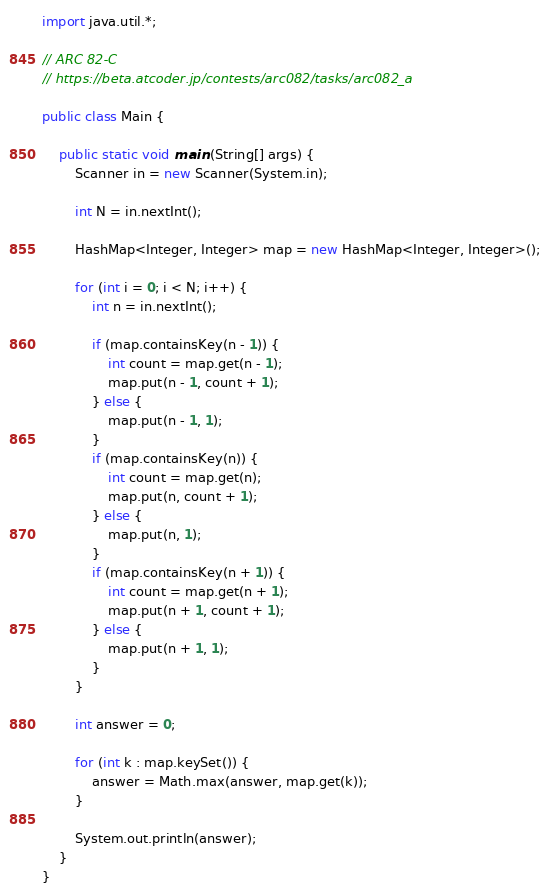Convert code to text. <code><loc_0><loc_0><loc_500><loc_500><_Java_>import java.util.*;

// ARC 82-C
// https://beta.atcoder.jp/contests/arc082/tasks/arc082_a

public class Main {

	public static void main (String[] args) {
		Scanner in = new Scanner(System.in);
		
		int N = in.nextInt();

		HashMap<Integer, Integer> map = new HashMap<Integer, Integer>();
		
		for (int i = 0; i < N; i++) {
			int n = in.nextInt();
			
			if (map.containsKey(n - 1)) {
				int count = map.get(n - 1);
				map.put(n - 1, count + 1);
			} else {
				map.put(n - 1, 1);
			}
			if (map.containsKey(n)) {
				int count = map.get(n);
				map.put(n, count + 1);
			} else {
				map.put(n, 1);
			}
			if (map.containsKey(n + 1)) {
				int count = map.get(n + 1);
				map.put(n + 1, count + 1);
			} else {
				map.put(n + 1, 1);
			}
		}
		
		int answer = 0;
		
		for (int k : map.keySet()) {
			answer = Math.max(answer, map.get(k));
		}
		
		System.out.println(answer);
	}
}

</code> 